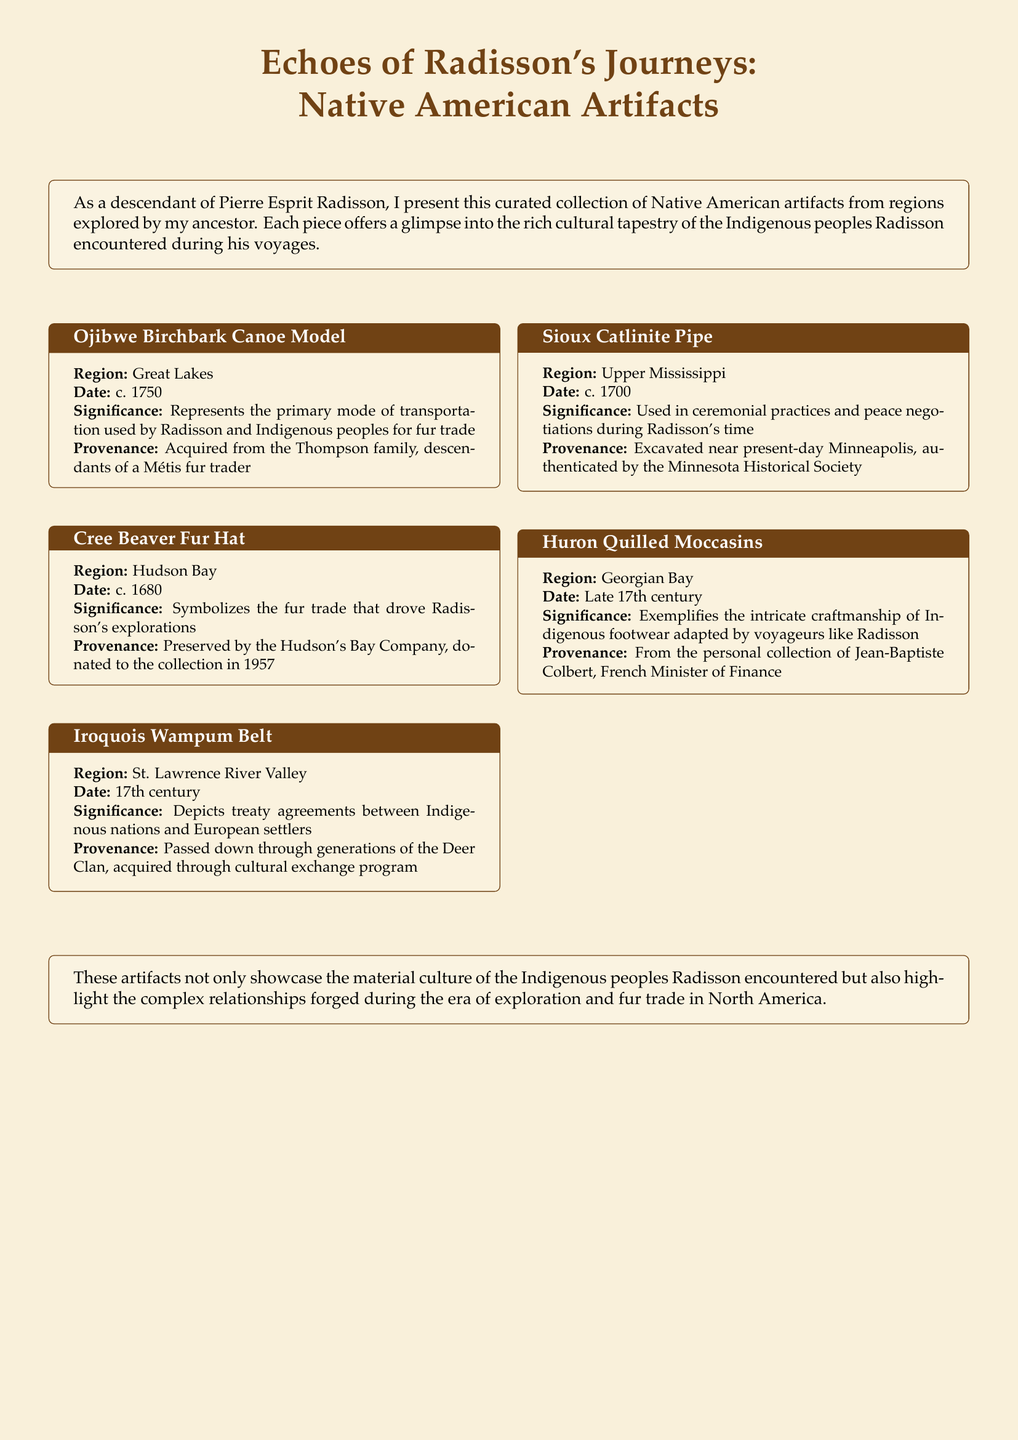What is the title of the collection? The title of the collection is presented at the top of the document.
Answer: Echoes of Radisson's Journeys: Native American Artifacts How many artifacts are listed in the collection? The collection features five artifacts, each detailed in a tcolorbox.
Answer: 5 What region does the Ojibwe Birchbark Canoe Model originate from? The specific region for the Ojibwe Birchbark Canoe Model is detailed within its description.
Answer: Great Lakes What is the date of the Cree Beaver Fur Hat? The date for the Cree Beaver Fur Hat is mentioned explicitly in its box.
Answer: c. 1680 What is the cultural significance of the Iroquois Wampum Belt? The document describes its significance in relation to treaty agreements.
Answer: Depicts treaty agreements between Indigenous nations and European settlers Who acquired the Sioux Catlinite Pipe? The provenance section indicates who was involved in acquiring the Sioux Catlinite Pipe.
Answer: Excavated near present-day Minneapolis What type of footwear is exemplified in the artifact from the Huron? The artifact from the Huron is related to a specific type of craft.
Answer: Quilled Moccasins Which organization preserved the Cree Beaver Fur Hat? The provenance section specifies which organization was responsible for preservation.
Answer: Hudson's Bay Company 